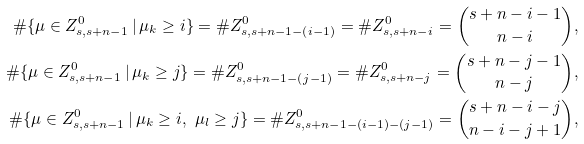<formula> <loc_0><loc_0><loc_500><loc_500>\# \{ \mu \in Z ^ { 0 } _ { s , s + n - 1 } \, | \, \mu _ { k } \geq i \} = \# Z ^ { 0 } _ { s , s + n - 1 - ( i - 1 ) } = \# Z ^ { 0 } _ { s , s + n - i } = \binom { s + n - i - 1 } { n - i } , \\ \# \{ \mu \in Z ^ { 0 } _ { s , s + n - 1 } \, | \, \mu _ { k } \geq j \} = \# Z ^ { 0 } _ { s , s + n - 1 - ( j - 1 ) } = \# Z ^ { 0 } _ { s , s + n - j } = \binom { s + n - j - 1 } { n - j } , \\ \# \{ \mu \in Z ^ { 0 } _ { s , s + n - 1 } \, | \, \mu _ { k } \geq i , \ \mu _ { l } \geq j \} = \# Z ^ { 0 } _ { s , s + n - 1 - ( i - 1 ) - ( j - 1 ) } = \binom { s + n - i - j } { n - i - j + 1 } ,</formula> 